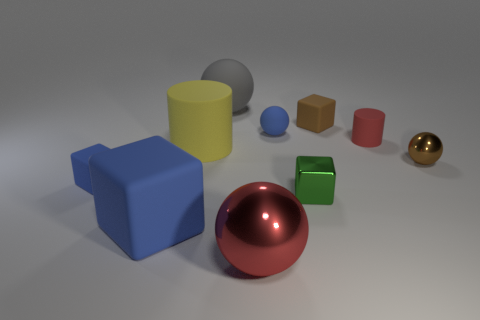Are there any other things of the same color as the metal cube?
Provide a short and direct response. No. How many things are tiny rubber cylinders or spheres in front of the brown sphere?
Give a very brief answer. 2. What is the material of the small blue thing left of the big matte object that is to the left of the matte cylinder that is to the left of the large gray matte object?
Give a very brief answer. Rubber. What is the size of the gray object that is made of the same material as the large yellow cylinder?
Make the answer very short. Large. There is a tiny sphere that is left of the shiny ball to the right of the small red matte object; what color is it?
Ensure brevity in your answer.  Blue. What number of spheres have the same material as the big blue object?
Keep it short and to the point. 2. What number of metal things are brown blocks or large blue cubes?
Provide a short and direct response. 0. What is the material of the red thing that is the same size as the blue sphere?
Make the answer very short. Rubber. Is there a tiny yellow thing made of the same material as the small red object?
Your answer should be compact. No. There is a object that is behind the brown object that is left of the red object that is to the right of the tiny green metal object; what is its shape?
Your answer should be very brief. Sphere. 